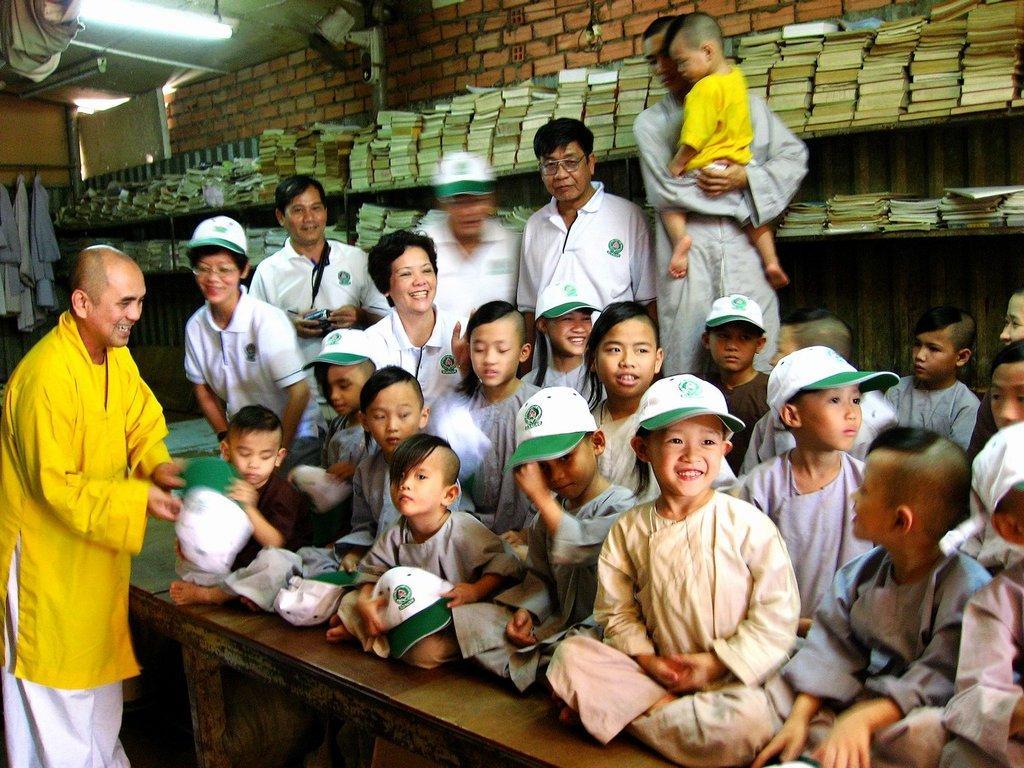Please provide a concise description of this image. A person is standing at the left wearing a yellow shirt and a white pant. There are children sitting on wooden surface wearing white dress and white and green caps. Few people are standing behind them. There are books in the shelves and there is a brick wall at the back. There are clothes hanging at the back. There is a cctv camera on the wall and a light on the top. 